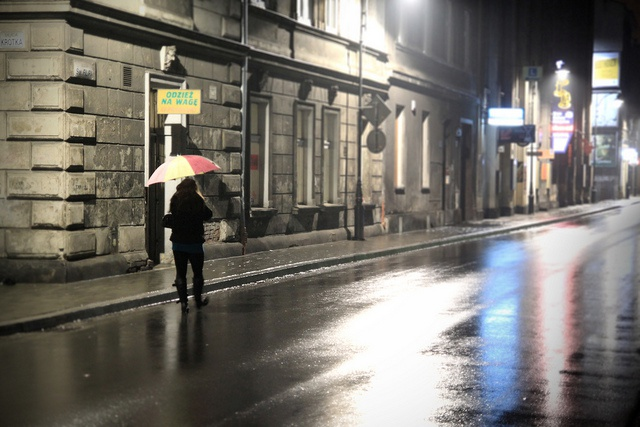Describe the objects in this image and their specific colors. I can see people in black and gray tones, umbrella in black, beige, khaki, and salmon tones, and handbag in black, gray, and darkgray tones in this image. 